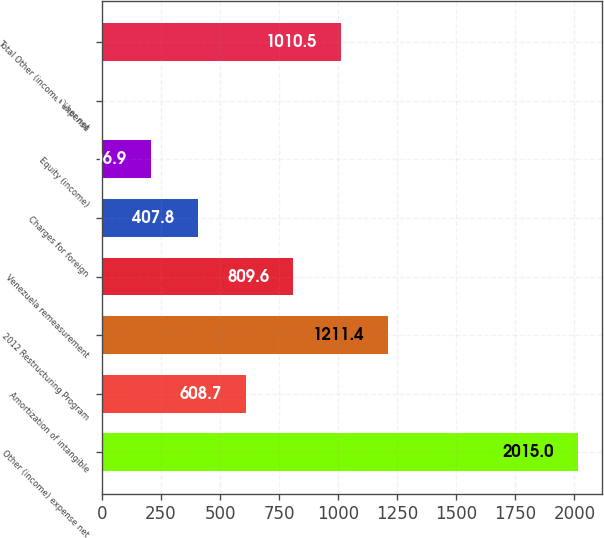Convert chart. <chart><loc_0><loc_0><loc_500><loc_500><bar_chart><fcel>Other (income) expense net<fcel>Amortization of intangible<fcel>2012 Restructuring Program<fcel>Venezuela remeasurement<fcel>Charges for foreign<fcel>Equity (income)<fcel>Other net<fcel>Total Other (income) expense<nl><fcel>2015<fcel>608.7<fcel>1211.4<fcel>809.6<fcel>407.8<fcel>206.9<fcel>6<fcel>1010.5<nl></chart> 